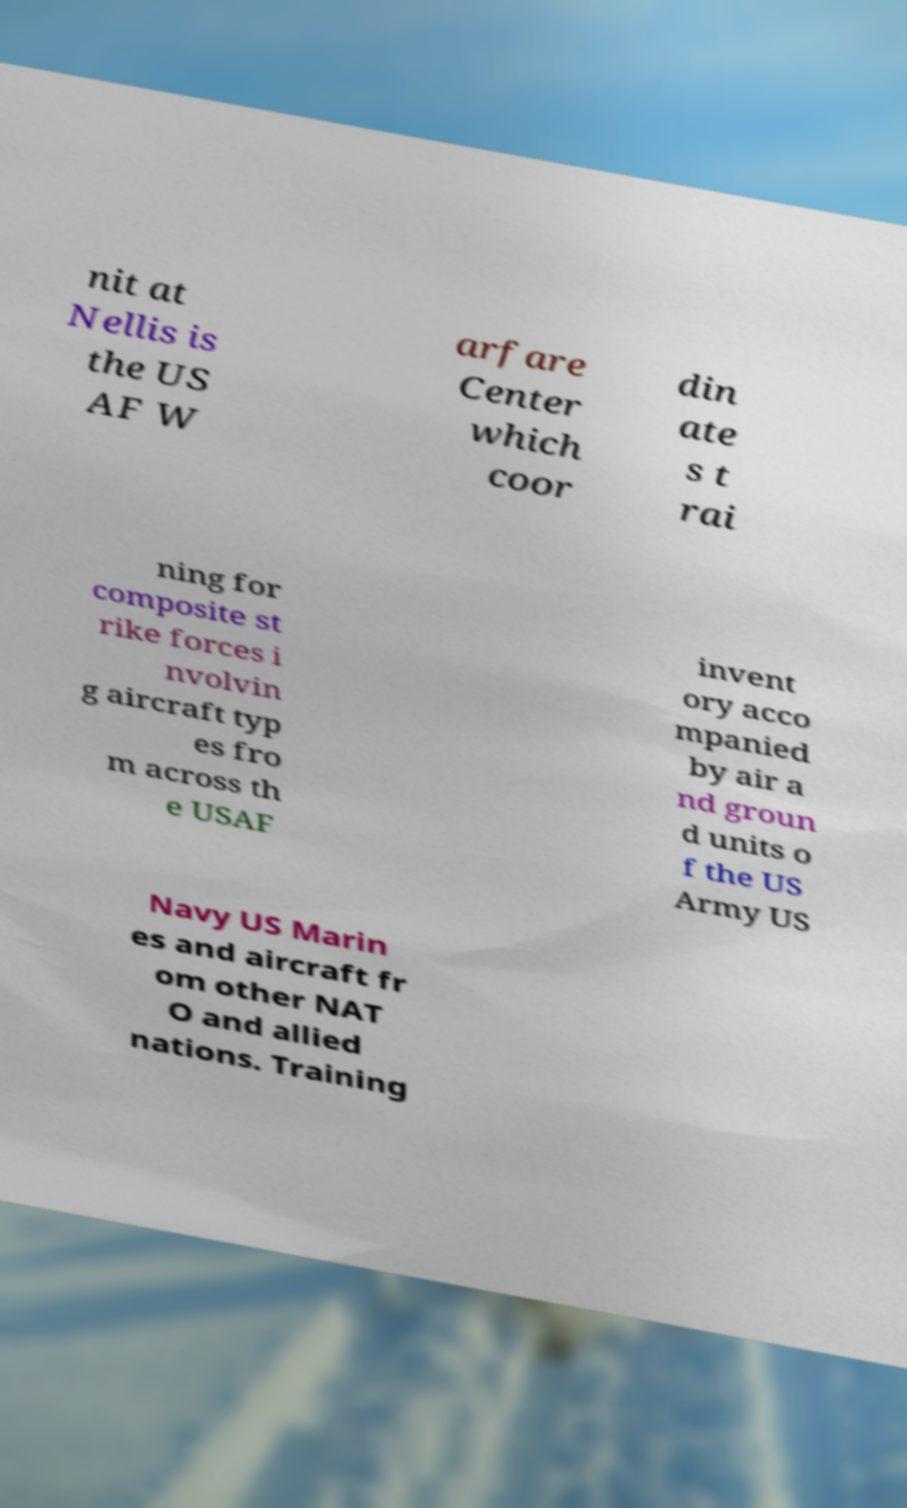I need the written content from this picture converted into text. Can you do that? nit at Nellis is the US AF W arfare Center which coor din ate s t rai ning for composite st rike forces i nvolvin g aircraft typ es fro m across th e USAF invent ory acco mpanied by air a nd groun d units o f the US Army US Navy US Marin es and aircraft fr om other NAT O and allied nations. Training 